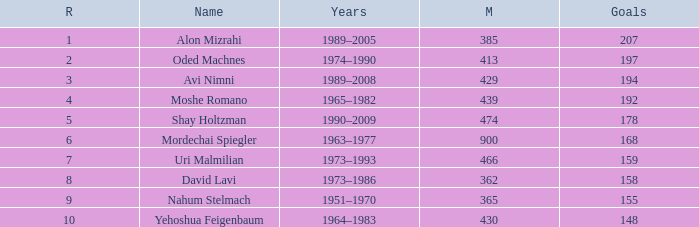What is the Rank of the player with 362 Matches? 8.0. 